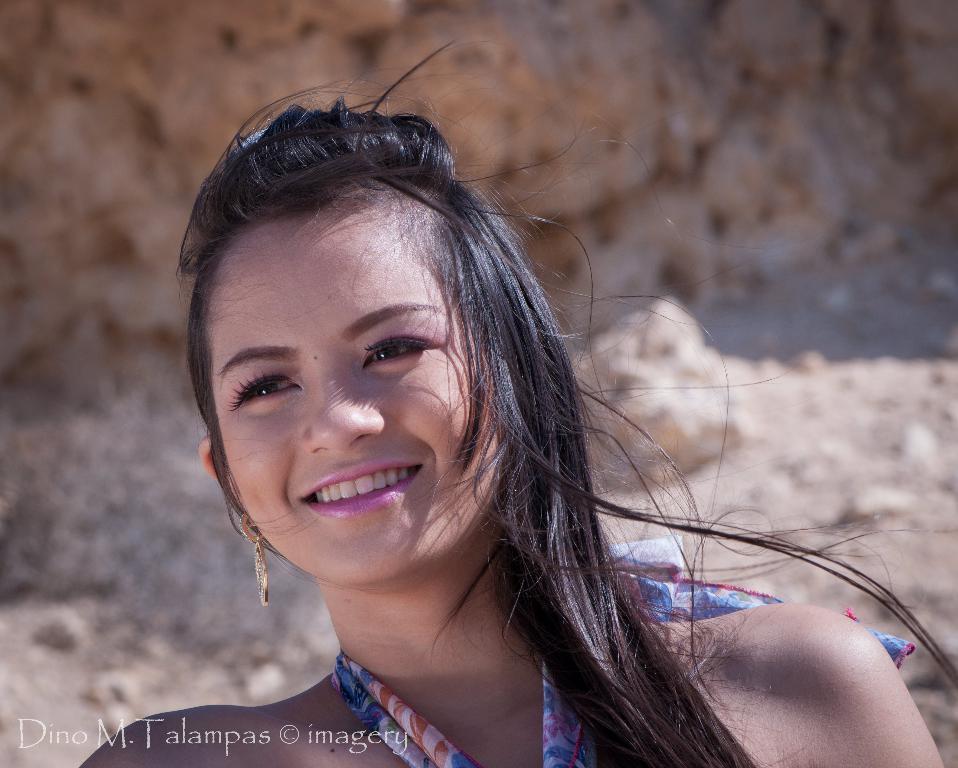Can you describe this image briefly? In this image in the front there is a woman smiling and in the background there are rocks. In the front on the bottom left of the image there is some text. 